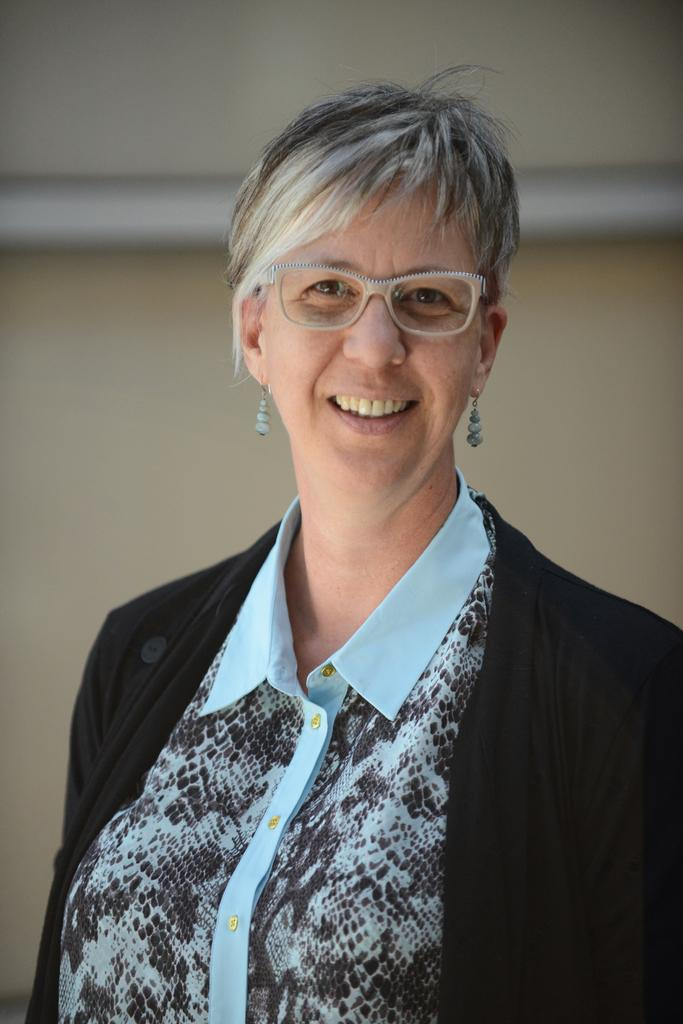Who is the main subject in the image? There is a lady in the image. What is the lady doing in the image? The lady is standing in the image. What is the lady's facial expression in the image? The lady is smiling in the image. What colors are present in the lady's outfit? The lady is wearing a blue shirt and a black coat in the image. What accessory is the lady wearing in the image? The lady is wearing specks in the image. What type of seed can be seen growing in the lady's stocking in the image? There is no seed or stocking present in the image; the lady is wearing a blue shirt and a black coat. 